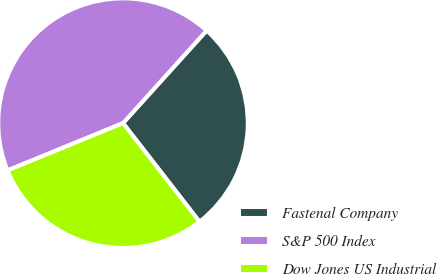Convert chart to OTSL. <chart><loc_0><loc_0><loc_500><loc_500><pie_chart><fcel>Fastenal Company<fcel>S&P 500 Index<fcel>Dow Jones US Industrial<nl><fcel>27.81%<fcel>42.88%<fcel>29.31%<nl></chart> 